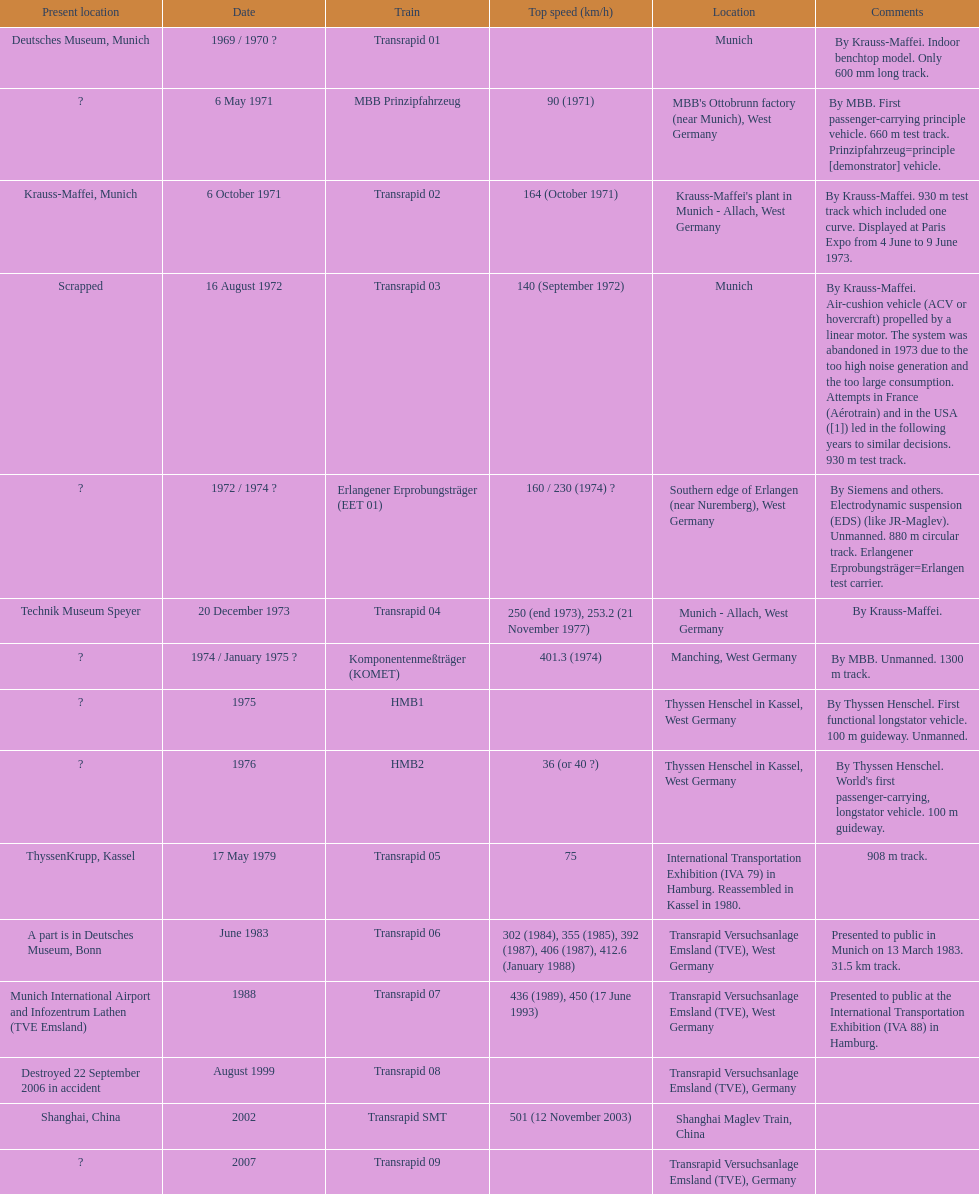What train was developed after the erlangener erprobungstrager? Transrapid 04. 